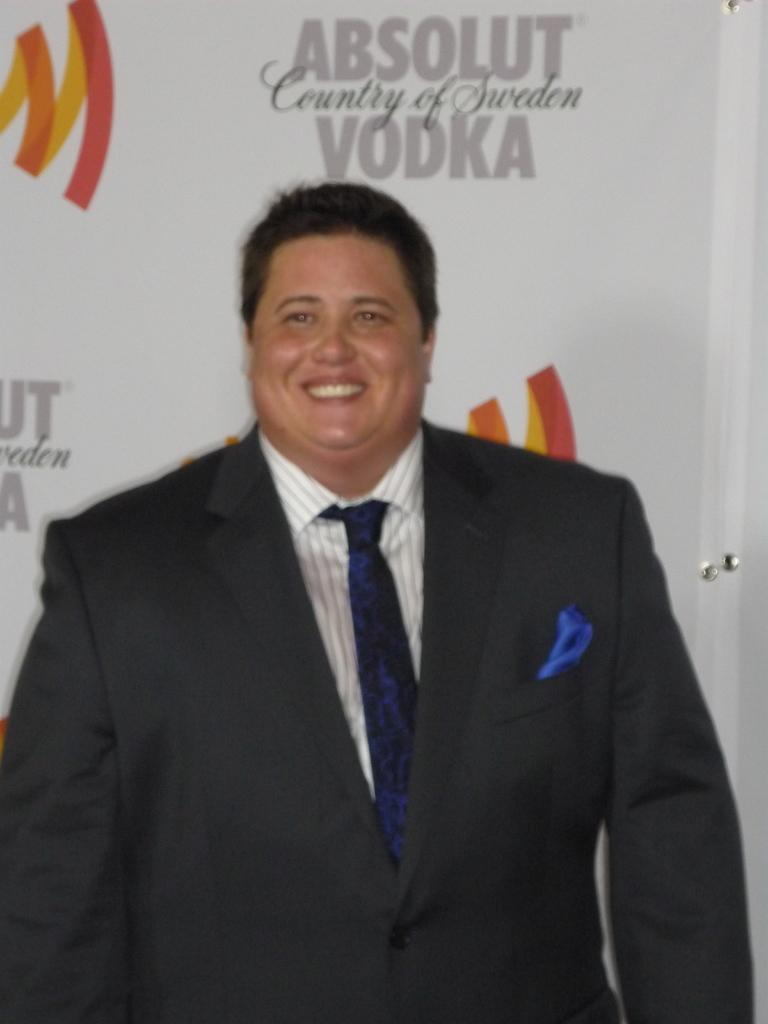Who is present in the image? There is a man in the image. What is the man doing in the image? The man is standing in the image. What type of clothing is the man wearing? The man is wearing a blazer in the image. What can be seen in the background of the image? There is a banner in the background of the image. How many spiders are crawling on the man's blazer in the image? There are no spiders visible on the man's blazer in the image. What type of calculator is the man holding in the image? The man is not holding a calculator in the image. 